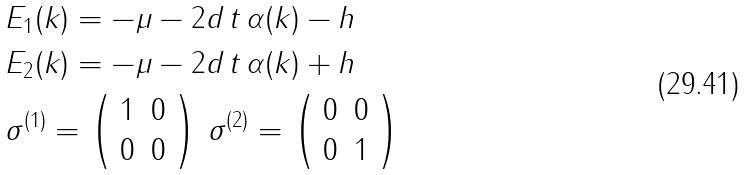<formula> <loc_0><loc_0><loc_500><loc_500>& E _ { 1 } ( k ) = - \mu - 2 d \, t \, \alpha ( k ) - h \\ & E _ { 2 } ( k ) = - \mu - 2 d \, t \, \alpha ( k ) + h \\ & \sigma ^ { ( 1 ) } = \left ( \begin{array} { c c } 1 & 0 \\ 0 & 0 \end{array} \right ) \, \sigma ^ { ( 2 ) } = \left ( \begin{array} { c c } 0 & 0 \\ 0 & 1 \end{array} \right )</formula> 